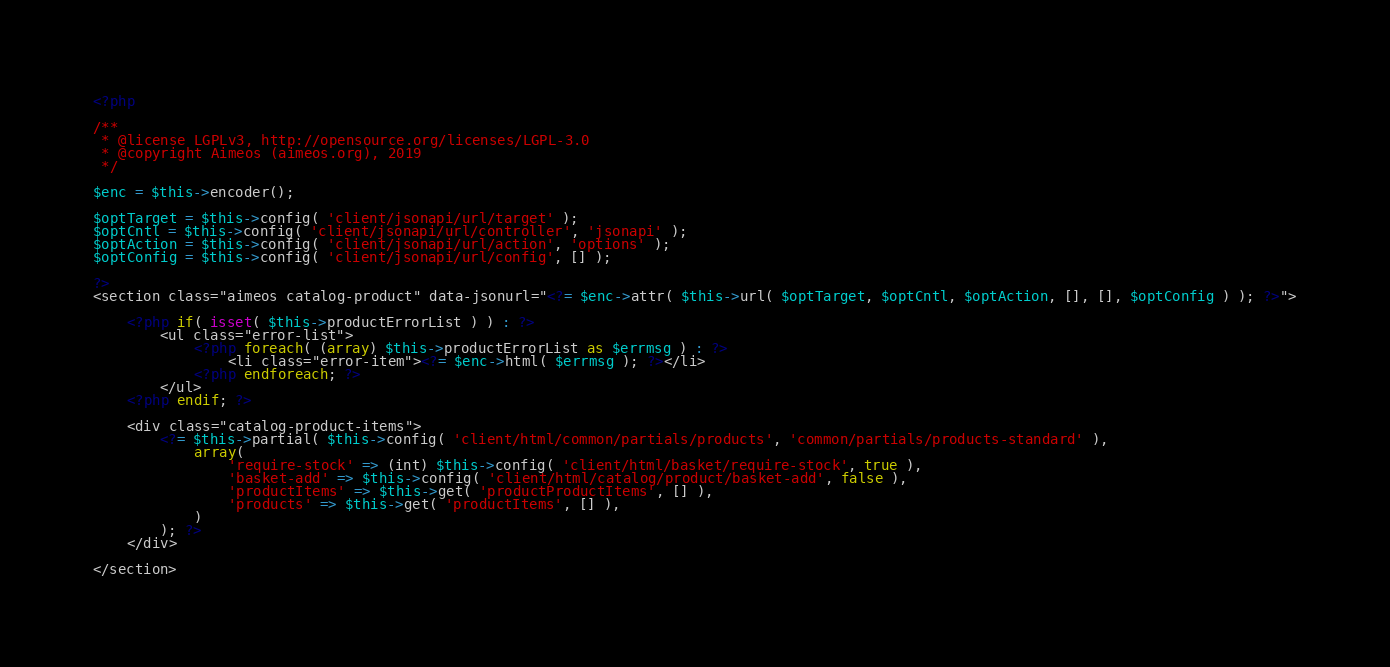Convert code to text. <code><loc_0><loc_0><loc_500><loc_500><_PHP_><?php

/**
 * @license LGPLv3, http://opensource.org/licenses/LGPL-3.0
 * @copyright Aimeos (aimeos.org), 2019
 */

$enc = $this->encoder();

$optTarget = $this->config( 'client/jsonapi/url/target' );
$optCntl = $this->config( 'client/jsonapi/url/controller', 'jsonapi' );
$optAction = $this->config( 'client/jsonapi/url/action', 'options' );
$optConfig = $this->config( 'client/jsonapi/url/config', [] );

?>
<section class="aimeos catalog-product" data-jsonurl="<?= $enc->attr( $this->url( $optTarget, $optCntl, $optAction, [], [], $optConfig ) ); ?>">

	<?php if( isset( $this->productErrorList ) ) : ?>
		<ul class="error-list">
			<?php foreach( (array) $this->productErrorList as $errmsg ) : ?>
				<li class="error-item"><?= $enc->html( $errmsg ); ?></li>
			<?php endforeach; ?>
		</ul>
	<?php endif; ?>

	<div class="catalog-product-items">
		<?= $this->partial( $this->config( 'client/html/common/partials/products', 'common/partials/products-standard' ),
			array(
				'require-stock' => (int) $this->config( 'client/html/basket/require-stock', true ),
				'basket-add' => $this->config( 'client/html/catalog/product/basket-add', false ),
				'productItems' => $this->get( 'productProductItems', [] ),
				'products' => $this->get( 'productItems', [] ),
			)
		); ?>
	</div>

</section>
</code> 